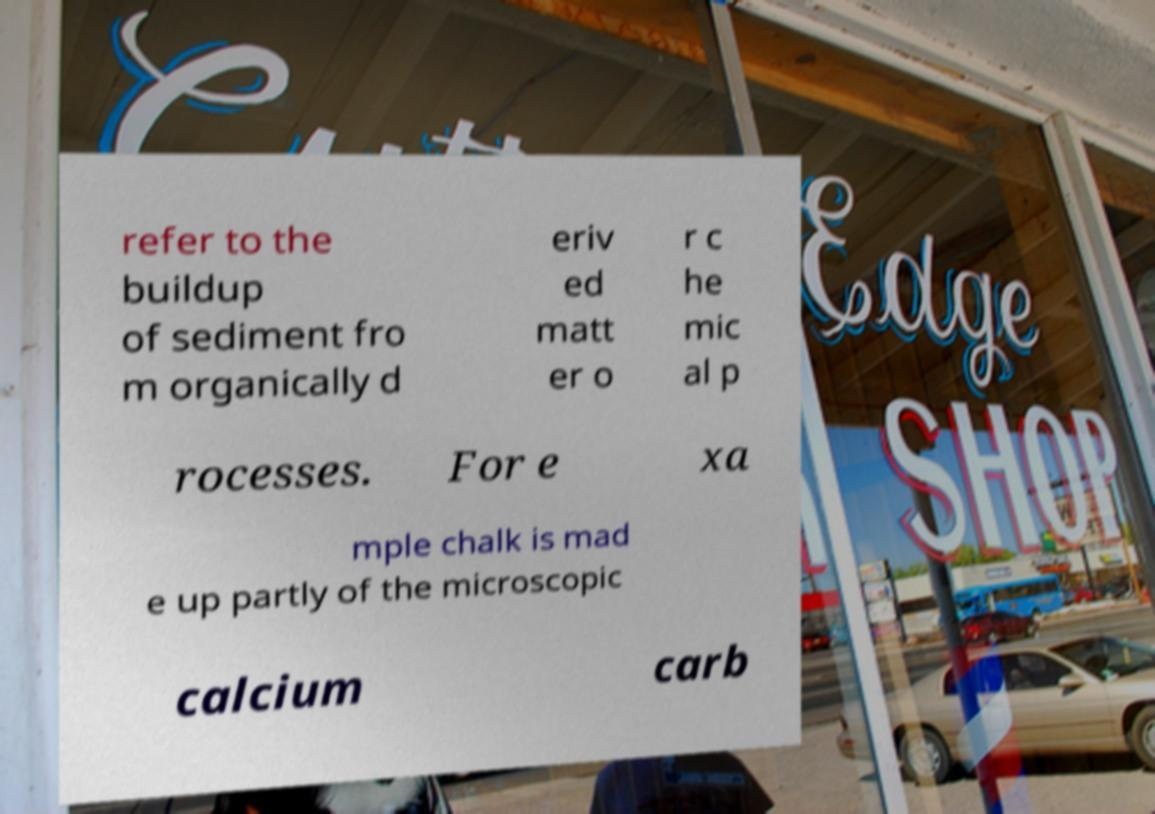What messages or text are displayed in this image? I need them in a readable, typed format. refer to the buildup of sediment fro m organically d eriv ed matt er o r c he mic al p rocesses. For e xa mple chalk is mad e up partly of the microscopic calcium carb 